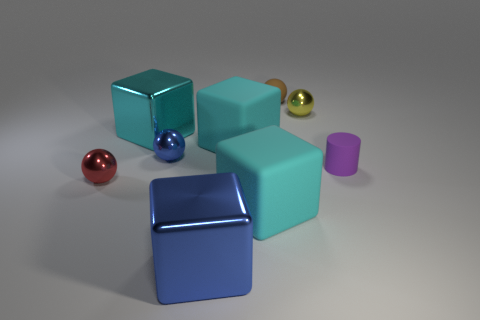Subtract all blue cubes. How many cubes are left? 3 Subtract 1 cylinders. How many cylinders are left? 0 Add 2 metal things. How many metal things exist? 7 Subtract all yellow spheres. How many spheres are left? 3 Subtract 1 cyan blocks. How many objects are left? 8 Subtract all cylinders. How many objects are left? 8 Subtract all blue blocks. Subtract all purple spheres. How many blocks are left? 3 Subtract all yellow spheres. How many yellow cylinders are left? 0 Subtract all brown rubber balls. Subtract all tiny brown matte objects. How many objects are left? 7 Add 4 big cyan shiny things. How many big cyan shiny things are left? 5 